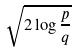Convert formula to latex. <formula><loc_0><loc_0><loc_500><loc_500>\sqrt { 2 \log \frac { p } { q } }</formula> 